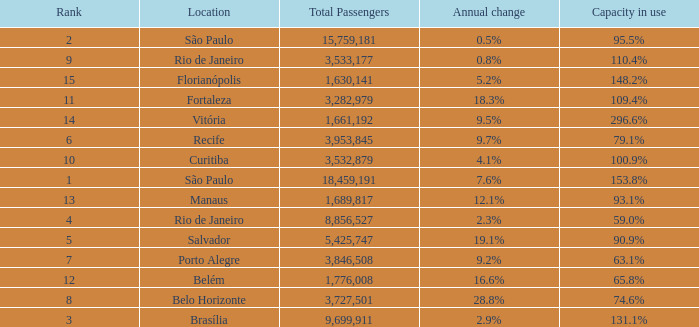What is the sum of Total Passengers when the annual change is 9.7% and the rank is less than 6? None. 